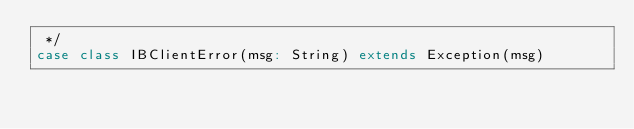Convert code to text. <code><loc_0><loc_0><loc_500><loc_500><_Scala_> */
case class IBClientError(msg: String) extends Exception(msg)
</code> 